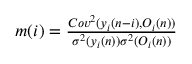<formula> <loc_0><loc_0><loc_500><loc_500>\begin{array} { r } { m ( i ) = \frac { C o v ^ { 2 } ( y _ { i } ( n - i ) , O _ { i } ( n ) ) } { \sigma ^ { 2 } ( y _ { i } ( n ) ) \sigma ^ { 2 } ( O _ { i } ( n ) ) } } \end{array}</formula> 